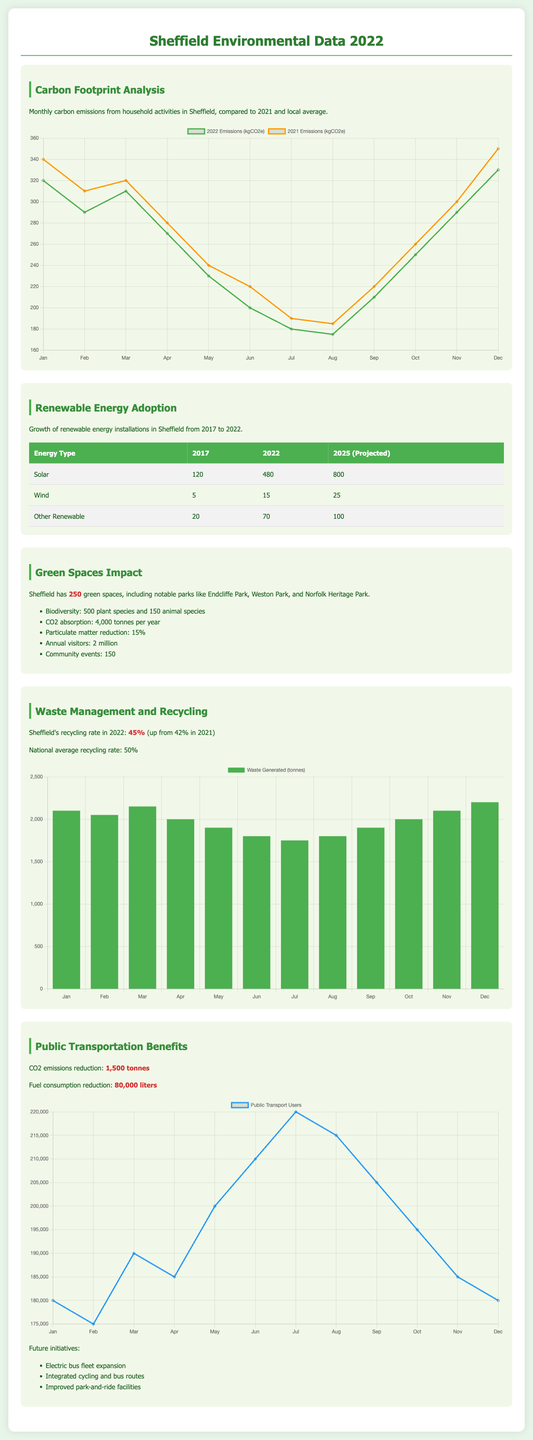What was the carbon emissions in January 2022? The document states that the carbon emissions for January 2022 was 320 kgCO2e according to the carbon emissions chart.
Answer: 320 kgCO2e How many green spaces are there in Sheffield? The section on green spaces highlights that there are a total of 250 green spaces in Sheffield.
Answer: 250 What is the recycling rate in Sheffield for 2022? The document specifies that Sheffield's recycling rate for 2022 is 45%, up from 42% in 2021.
Answer: 45% How many solar installations were there in Sheffield in 2022? In the renewable energy table, it is shown that there were 480 solar installations in Sheffield in 2022.
Answer: 480 What percentage reduction in particulate matter do green spaces contribute? The overview of green spaces mentions a reduction of 15% in particulate matter due to the green spaces.
Answer: 15% What is the projected number of wind installations for 2025? The renewable energy data shows that the projected number of wind installations for 2025 is 25.
Answer: 25 How much CO2 emissions were reduced through public transportation in Sheffield? The document specifies that CO2 emissions were reduced by 1,500 tonnes through public transportation initiatives.
Answer: 1,500 tonnes What is the national average recycling rate that Sheffield is compared to? It mentions that the national average recycling rate is 50% in the waste management section.
Answer: 50% 